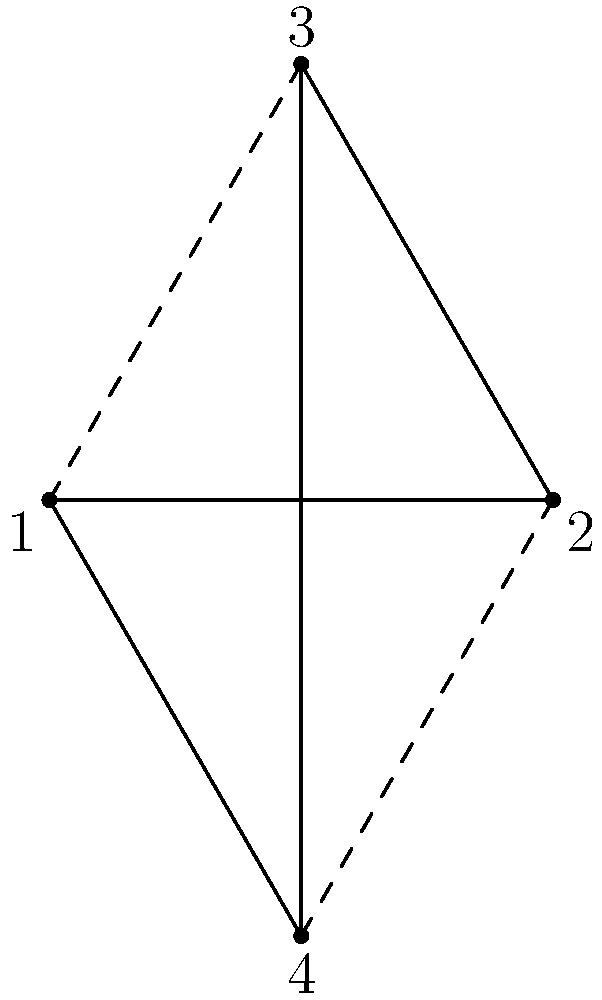Consider a relay race team with four runners, represented by the vertices of a square as shown in the diagram. The team formation can be rotated clockwise by 90 degrees, creating a cyclic group. What is the order of this group, and how many unique formations can be created? To determine the order of the cyclic group and the number of unique formations:

1. Analyze the rotations:
   - 0° rotation (identity): (1,2,3,4)
   - 90° clockwise rotation: (4,1,2,3)
   - 180° rotation: (3,4,1,2)
   - 270° clockwise rotation: (2,3,4,1)

2. Count the number of unique rotations:
   There are 4 unique rotations, as the next 90° rotation would return to the initial position.

3. Determine the order of the group:
   The order of a cyclic group is equal to the number of elements in the group. In this case, it's 4.

4. Identify the number of unique formations:
   Each rotation creates a unique formation, so there are 4 unique formations.

5. Relate to group theory:
   This forms a cyclic group of order 4, denoted as $C_4$ or $\mathbb{Z}_4$.

Therefore, the order of the group is 4, and there are 4 unique formations.
Answer: Order: 4, Unique formations: 4 